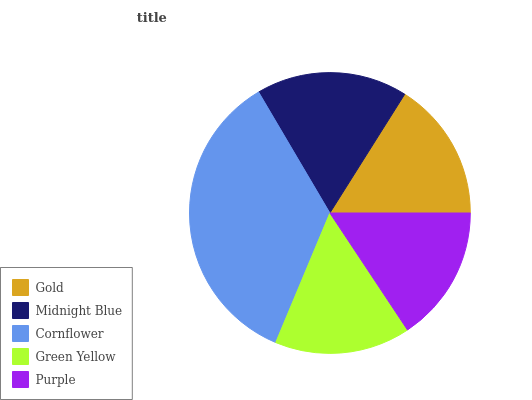Is Green Yellow the minimum?
Answer yes or no. Yes. Is Cornflower the maximum?
Answer yes or no. Yes. Is Midnight Blue the minimum?
Answer yes or no. No. Is Midnight Blue the maximum?
Answer yes or no. No. Is Midnight Blue greater than Gold?
Answer yes or no. Yes. Is Gold less than Midnight Blue?
Answer yes or no. Yes. Is Gold greater than Midnight Blue?
Answer yes or no. No. Is Midnight Blue less than Gold?
Answer yes or no. No. Is Gold the high median?
Answer yes or no. Yes. Is Gold the low median?
Answer yes or no. Yes. Is Purple the high median?
Answer yes or no. No. Is Green Yellow the low median?
Answer yes or no. No. 